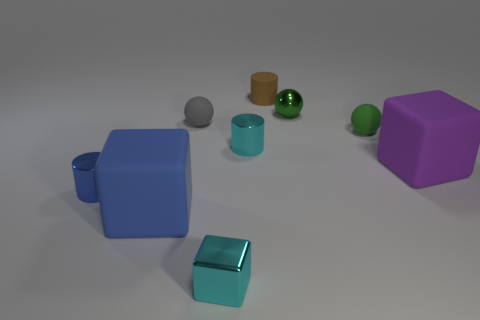Are there any other things that are made of the same material as the big purple cube?
Your response must be concise. Yes. There is a big rubber object that is on the right side of the cyan thing that is in front of the rubber cube that is right of the tiny green matte object; what is its shape?
Provide a succinct answer. Cube. What is the color of the other thing that is the same size as the purple rubber thing?
Make the answer very short. Blue. How many cylinders are either matte things or brown things?
Offer a terse response. 1. What number of matte blocks are there?
Provide a succinct answer. 2. There is a large purple matte object; is it the same shape as the small cyan thing that is in front of the tiny blue metal thing?
Make the answer very short. Yes. What size is the rubber ball that is the same color as the tiny metallic sphere?
Your response must be concise. Small. What number of objects are either small green things or tiny cyan things?
Provide a short and direct response. 4. What shape is the tiny cyan metallic thing that is behind the cyan shiny thing in front of the big purple rubber block?
Offer a very short reply. Cylinder. There is a tiny metallic thing that is in front of the big blue block; is its shape the same as the big purple rubber thing?
Ensure brevity in your answer.  Yes. 